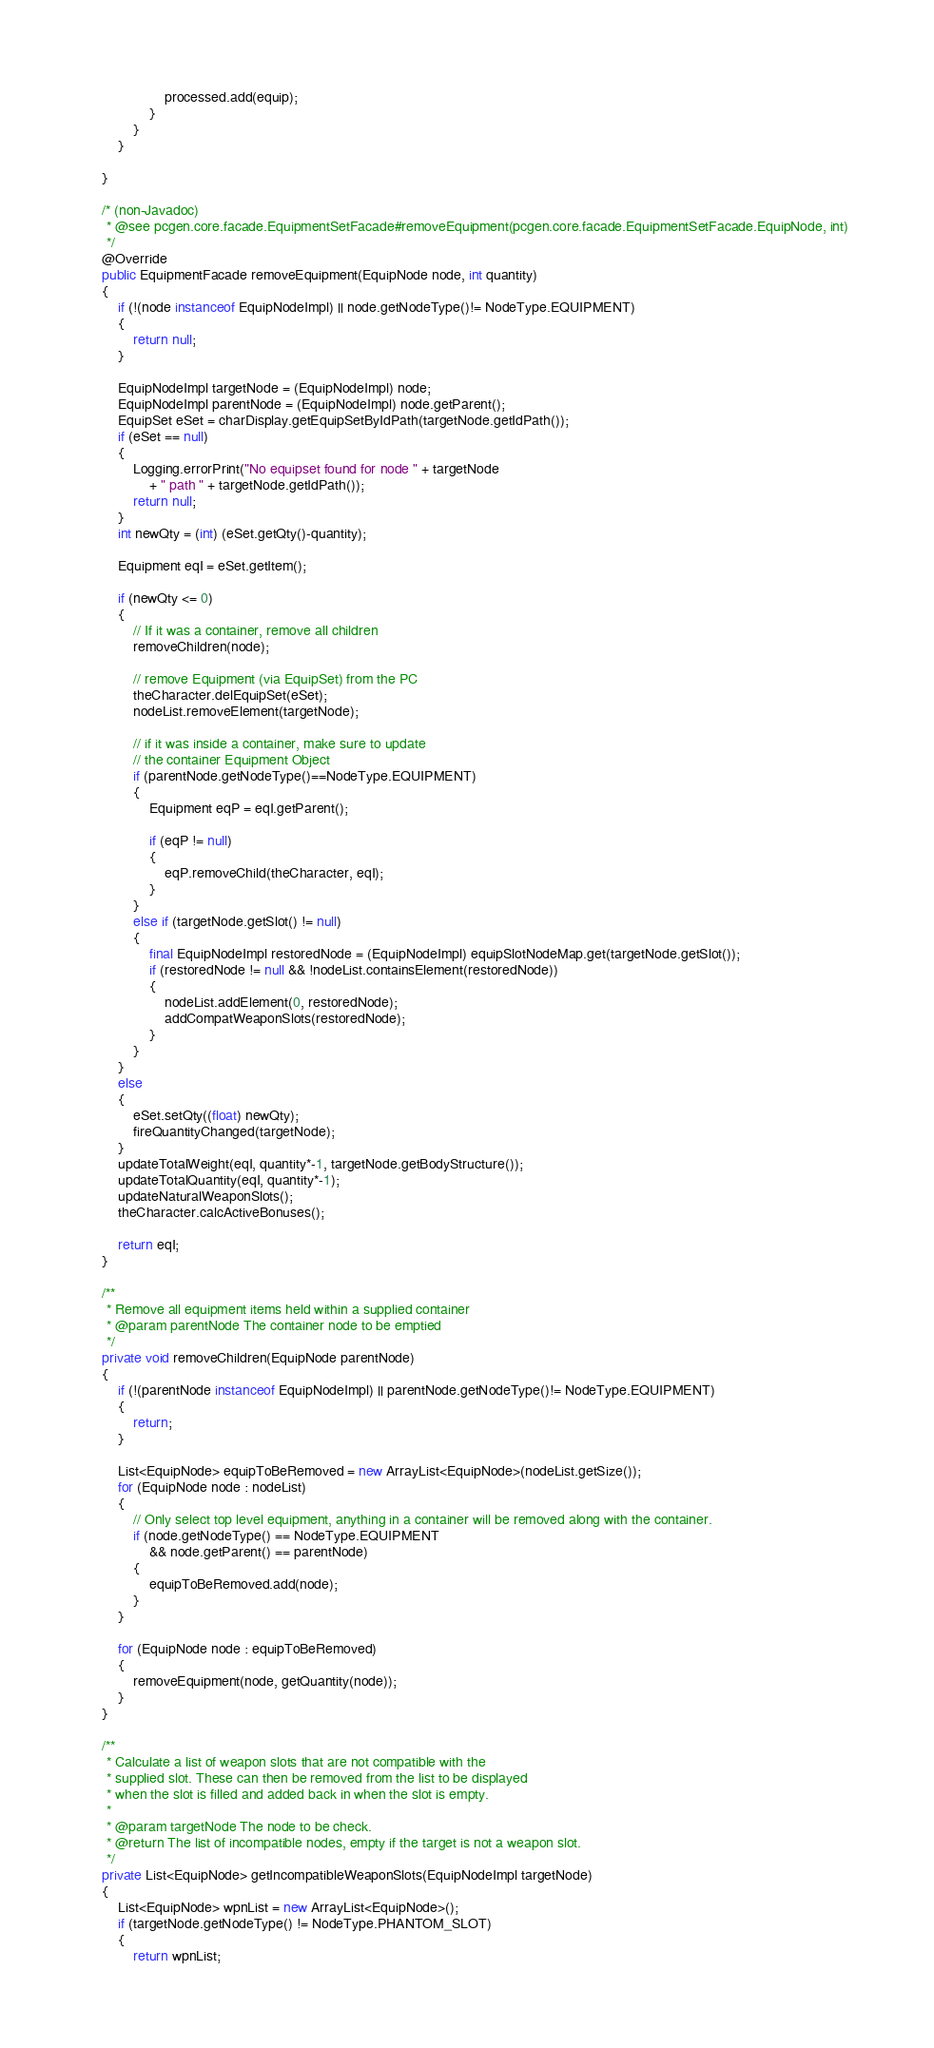<code> <loc_0><loc_0><loc_500><loc_500><_Java_>					processed.add(equip);
				}
			}
		}

	}

	/* (non-Javadoc)
	 * @see pcgen.core.facade.EquipmentSetFacade#removeEquipment(pcgen.core.facade.EquipmentSetFacade.EquipNode, int)
	 */
	@Override
	public EquipmentFacade removeEquipment(EquipNode node, int quantity)
	{
		if (!(node instanceof EquipNodeImpl) || node.getNodeType()!= NodeType.EQUIPMENT)
		{
			return null;
		}
		
		EquipNodeImpl targetNode = (EquipNodeImpl) node;
		EquipNodeImpl parentNode = (EquipNodeImpl) node.getParent();
		EquipSet eSet = charDisplay.getEquipSetByIdPath(targetNode.getIdPath());
		if (eSet == null)
		{
			Logging.errorPrint("No equipset found for node " + targetNode
				+ " path " + targetNode.getIdPath());
			return null;
		}
		int newQty = (int) (eSet.getQty()-quantity);

		Equipment eqI = eSet.getItem();
		
		if (newQty <= 0)
		{
			// If it was a container, remove all children
			removeChildren(node);

			// remove Equipment (via EquipSet) from the PC
			theCharacter.delEquipSet(eSet);
			nodeList.removeElement(targetNode);
	
			// if it was inside a container, make sure to update
			// the container Equipment Object
			if (parentNode.getNodeType()==NodeType.EQUIPMENT)
			{
				Equipment eqP = eqI.getParent();
	
				if (eqP != null)
				{
					eqP.removeChild(theCharacter, eqI);
				}
			}
			else if (targetNode.getSlot() != null)
			{
				final EquipNodeImpl restoredNode = (EquipNodeImpl) equipSlotNodeMap.get(targetNode.getSlot());
				if (restoredNode != null && !nodeList.containsElement(restoredNode))
				{
					nodeList.addElement(0, restoredNode);
					addCompatWeaponSlots(restoredNode);
				}
			}
		}
		else
		{
			eSet.setQty((float) newQty);
			fireQuantityChanged(targetNode);
		}
		updateTotalWeight(eqI, quantity*-1, targetNode.getBodyStructure());
		updateTotalQuantity(eqI, quantity*-1);
		updateNaturalWeaponSlots();
		theCharacter.calcActiveBonuses();
		
		return eqI;
	}

	/**
	 * Remove all equipment items held within a supplied container
	 * @param parentNode The container node to be emptied
	 */
	private void removeChildren(EquipNode parentNode)
	{
		if (!(parentNode instanceof EquipNodeImpl) || parentNode.getNodeType()!= NodeType.EQUIPMENT)
		{
			return;
		}

		List<EquipNode> equipToBeRemoved = new ArrayList<EquipNode>(nodeList.getSize());
		for (EquipNode node : nodeList)
		{
			// Only select top level equipment, anything in a container will be removed along with the container. 
			if (node.getNodeType() == NodeType.EQUIPMENT
				&& node.getParent() == parentNode)
			{
				equipToBeRemoved.add(node);
			}
		}

		for (EquipNode node : equipToBeRemoved)
		{
			removeEquipment(node, getQuantity(node));
		}
	}

	/**
	 * Calculate a list of weapon slots that are not compatible with the 
	 * supplied slot. These can then be removed from the list to be displayed 
	 * when the slot is filled and added back in when the slot is empty. 
	 * 
	 * @param targetNode The node to be check.
	 * @return The list of incompatible nodes, empty if the target is not a weapon slot.
	 */
	private List<EquipNode> getIncompatibleWeaponSlots(EquipNodeImpl targetNode)
	{
		List<EquipNode> wpnList = new ArrayList<EquipNode>();
		if (targetNode.getNodeType() != NodeType.PHANTOM_SLOT)
		{
			return wpnList;</code> 